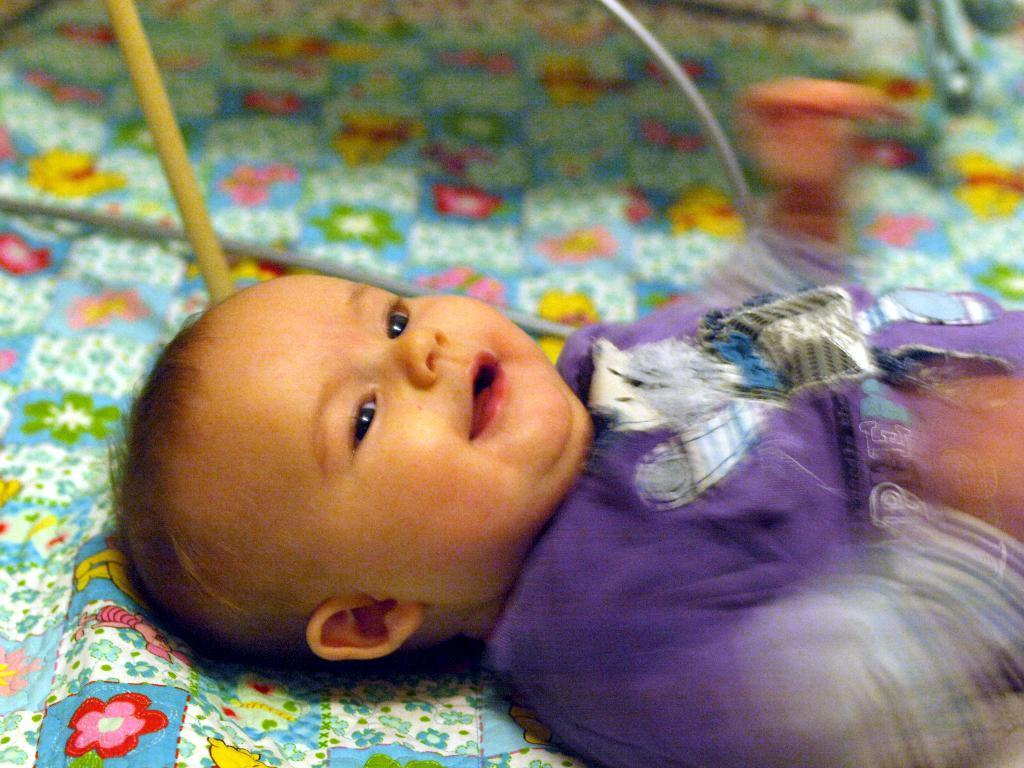What is the main subject of the picture? The main subject of the picture is a small baby. What is the baby wearing in the picture? The baby is wearing a purple dress. What is the baby's facial expression in the picture? The baby is smiling. Where is the baby located in the picture? The baby is lying on a bed. What type of rings can be seen on the baby's fingers in the picture? There are no rings visible on the baby's fingers in the image. What time of day is it in the picture, considering the baby's morning routine? The time of day cannot be determined from the image, as there is no indication of a morning routine or any specific time of day. 